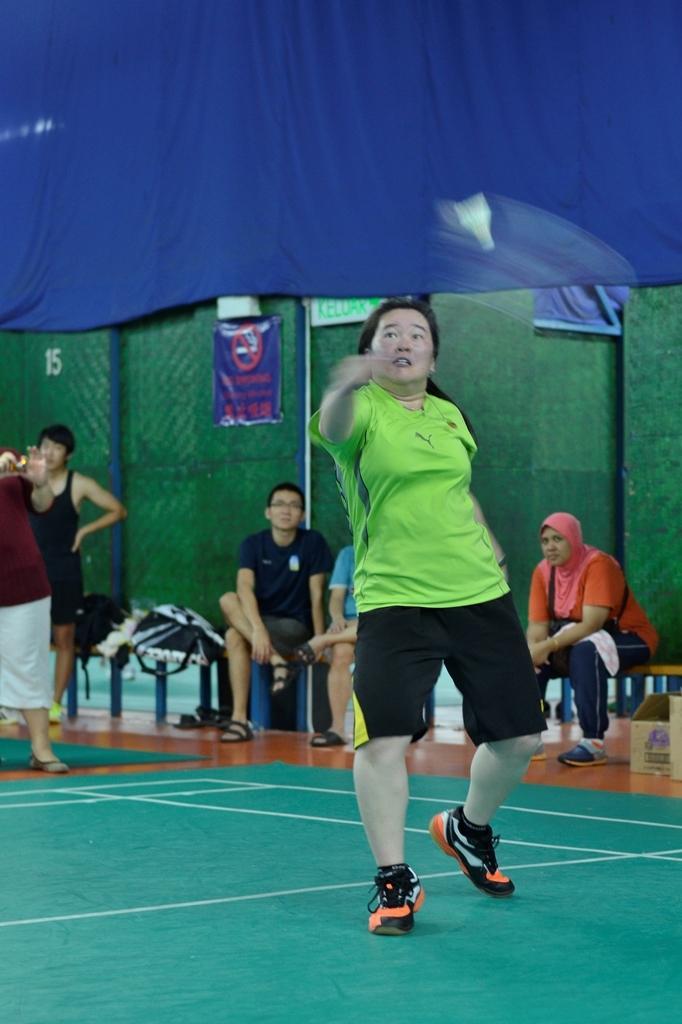In one or two sentences, can you explain what this image depicts? In the foreground of this image, there is a person standing holding a racket and hitting a cock. In the background, there are three people sitting on a bench and two are standing on the floor. We can also see two bags, a green wall on which there is a blue poster and at the top, there is a blue curtain. 